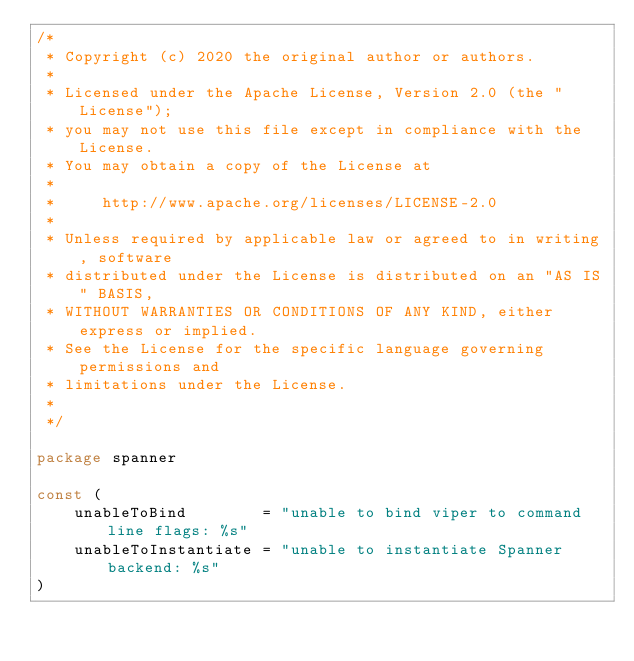<code> <loc_0><loc_0><loc_500><loc_500><_Go_>/*
 * Copyright (c) 2020 the original author or authors.
 *
 * Licensed under the Apache License, Version 2.0 (the "License");
 * you may not use this file except in compliance with the License.
 * You may obtain a copy of the License at
 *
 *     http://www.apache.org/licenses/LICENSE-2.0
 *
 * Unless required by applicable law or agreed to in writing, software
 * distributed under the License is distributed on an "AS IS" BASIS,
 * WITHOUT WARRANTIES OR CONDITIONS OF ANY KIND, either express or implied.
 * See the License for the specific language governing permissions and
 * limitations under the License.
 *
 */

package spanner

const (
	unableToBind        = "unable to bind viper to command line flags: %s"
	unableToInstantiate = "unable to instantiate Spanner backend: %s"
)
</code> 